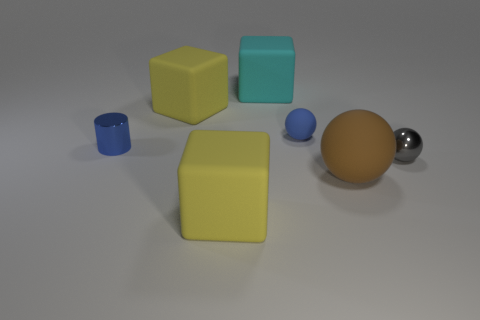There is a blue thing that is to the right of the cyan rubber cube; is it the same size as the matte sphere that is on the right side of the tiny matte thing?
Your answer should be very brief. No. Are there more objects that are in front of the small shiny sphere than small cylinders to the right of the large cyan matte block?
Your response must be concise. Yes. What number of other things have the same shape as the big cyan thing?
Ensure brevity in your answer.  2. There is a cylinder that is the same size as the gray metallic thing; what is its material?
Make the answer very short. Metal. Are there any brown balls that have the same material as the big cyan thing?
Offer a terse response. Yes. Are there fewer blue objects that are to the right of the tiny gray sphere than big brown cubes?
Offer a very short reply. No. What material is the small object left of the large yellow rubber cube that is in front of the gray object?
Your answer should be compact. Metal. There is a tiny thing that is on the right side of the small cylinder and left of the brown ball; what is its shape?
Give a very brief answer. Sphere. How many other objects are the same color as the metal sphere?
Offer a terse response. 0. How many objects are yellow rubber things in front of the tiny gray thing or big yellow objects?
Keep it short and to the point. 2. 